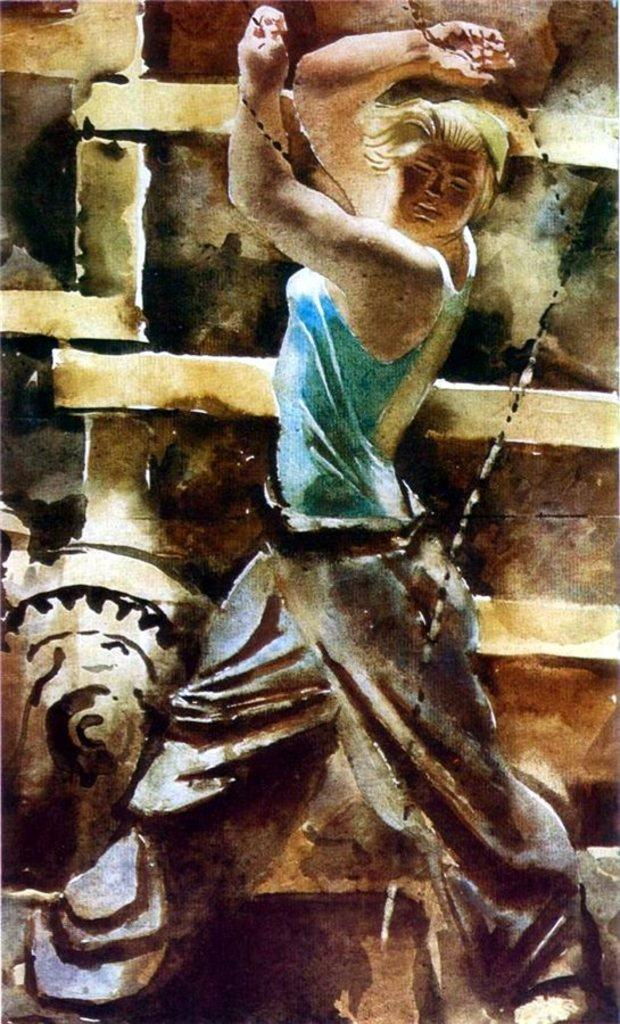What is depicted in the image? There is a sketch of a person in the image. What else can be seen in the image besides the sketch? There is a wall in the image. What type of war is being depicted in the image? There is no depiction of war in the image; it features a sketch of a person and a wall. What is the hand doing in the image? There is no hand present in the image. --- Facts: 1. There is a person holding a book in the image. 2. The person is sitting on a chair. 3. There is a table in the image. 4. The table has a lamp on it. Absurd Topics: elephant, ocean, spaceship Conversation: What is the person in the image holding? The person in the image is holding a book. What is the person's position in the image? The person is sitting on a chair. What other piece of furniture is present in the image? There is a table in the image. What object is on the table in the image? The table has a lamp on it. Reasoning: Let's think step by step in order to produce the conversation. We start by identifying the main subject in the image, which is the person holding a book. Then, we expand the conversation to include other elements that are also visible, such as the person's position, the presence of a table, and the object on the table. Each question is designed to elicit a specific detail about the image that is known from the provided facts. Absurd Question/Answer: Can you see an elephant swimming in the ocean in the image? There is no elephant or ocean present in the image; it features a person holding a book, sitting on a chair, and a table with a lamp on it. What type of spaceship is visible in the image? There is no spaceship present in the image. 